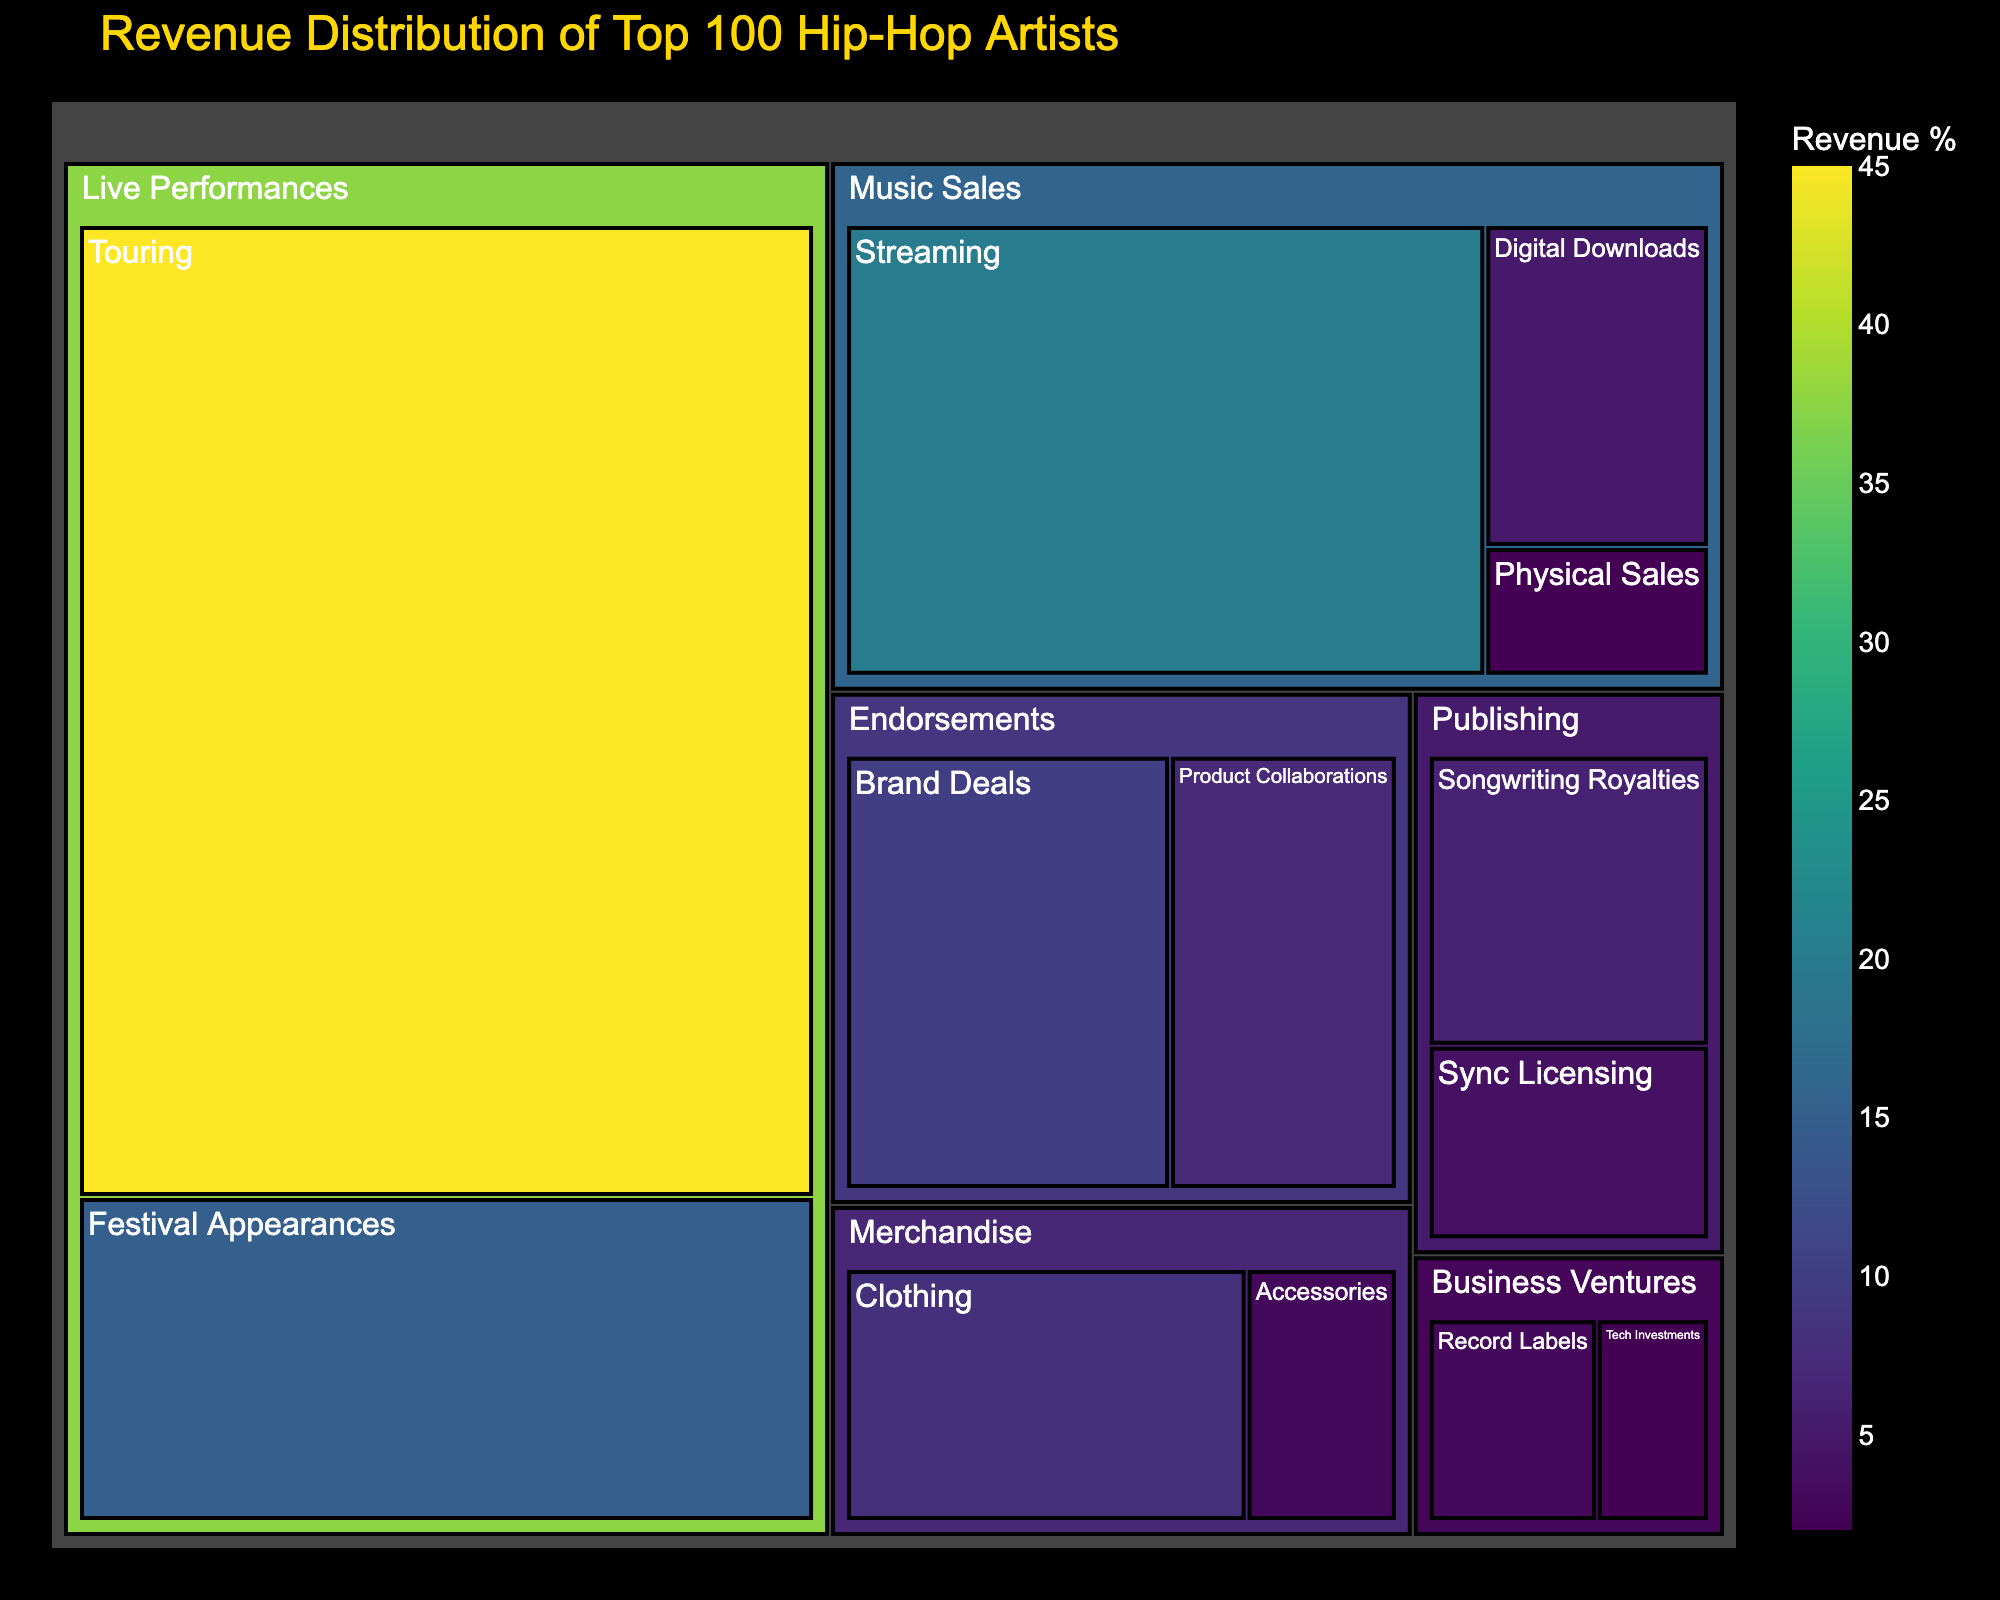What is the title of the figure? The title of the figure is usually placed at the top and is generally the text with the largest font size.
Answer: Revenue Distribution of Top 100 Hip-Hop Artists Which category has the highest revenue percentage? By visually examining the largest area in the treemap where the labels grow in size with value, it's clear that the largest is 'Touring', under 'Live Performances'.
Answer: Live Performances How much revenue does 'Streaming' contribute compared to 'Touring'? First locate the revenue percentages of 'Streaming' and 'Touring'. 'Streaming' is 20% and 'Touring' is 45%. To find the comparison, examine their difference and ratio.
Answer: Streaming contributes 20%, while Touring contributes 45%. So, Touring's revenue is more than double ('Streaming' has 20% and 'Touring' has 45%) Which subcategory under 'Merchandise' has the higher revenue percentage? Check the two subcategories under 'Merchandise', which are 'Clothing' and 'Accessories'. Compare their values.
Answer: Clothing (8%) has a higher revenue percentage than Accessories (3%) What is the total revenue percentage for 'Endorsements'? Sum the revenue percentages of subcategories under 'Endorsements', which includes 'Brand Deals' at 10% and 'Product Collaborations' at 7%.
Answer: The total revenue percentage for Endorsements is 17% Between 'Digital Downloads' and 'Physical Sales', which subcategory of 'Music Sales' has a lower revenue percentage and by how much? Identify the revenue percentages: 'Digital Downloads' is at 5% and 'Physical Sales' is at 2%. Subtract the percentage of the lower value from the higher value.
Answer: Physical Sales (2%) is lower by 3% What is the combined revenue percentage of all subcategories under 'Publishing'? Add the revenue percentages of 'Songwriting Royalties' (6%) and 'Sync Licensing' (4%).
Answer: The combined revenue percentage of all subcategories under 'Publishing' is 10% Which subcategory under 'Business Ventures' has the lower revenue percentage, and what is its value? Look at the subcategories under 'Business Ventures': 'Record Labels' (3%) and 'Tech Investments' (2%). Identify the lower value.
Answer: Tech Investments (2%) How does the revenue from 'Clothing' compare to 'Tech Investments'? 'Clothing' under 'Merchandise' has 8% revenue, while 'Tech Investments' under 'Business Ventures' has 2% revenue. Compare these values.
Answer: Clothing (8%) revenue is significantly higher than Tech Investments (2%) What is the average revenue percentage of subcategories under 'Live Performances'? Add the percentages of 'Touring' (45%) and 'Festival Appearances' (15%), then divide by the number of subcategories. (45 + 15) / 2 = 30.
Answer: The average revenue percentage of subcategories under 'Live Performances' is 30% 